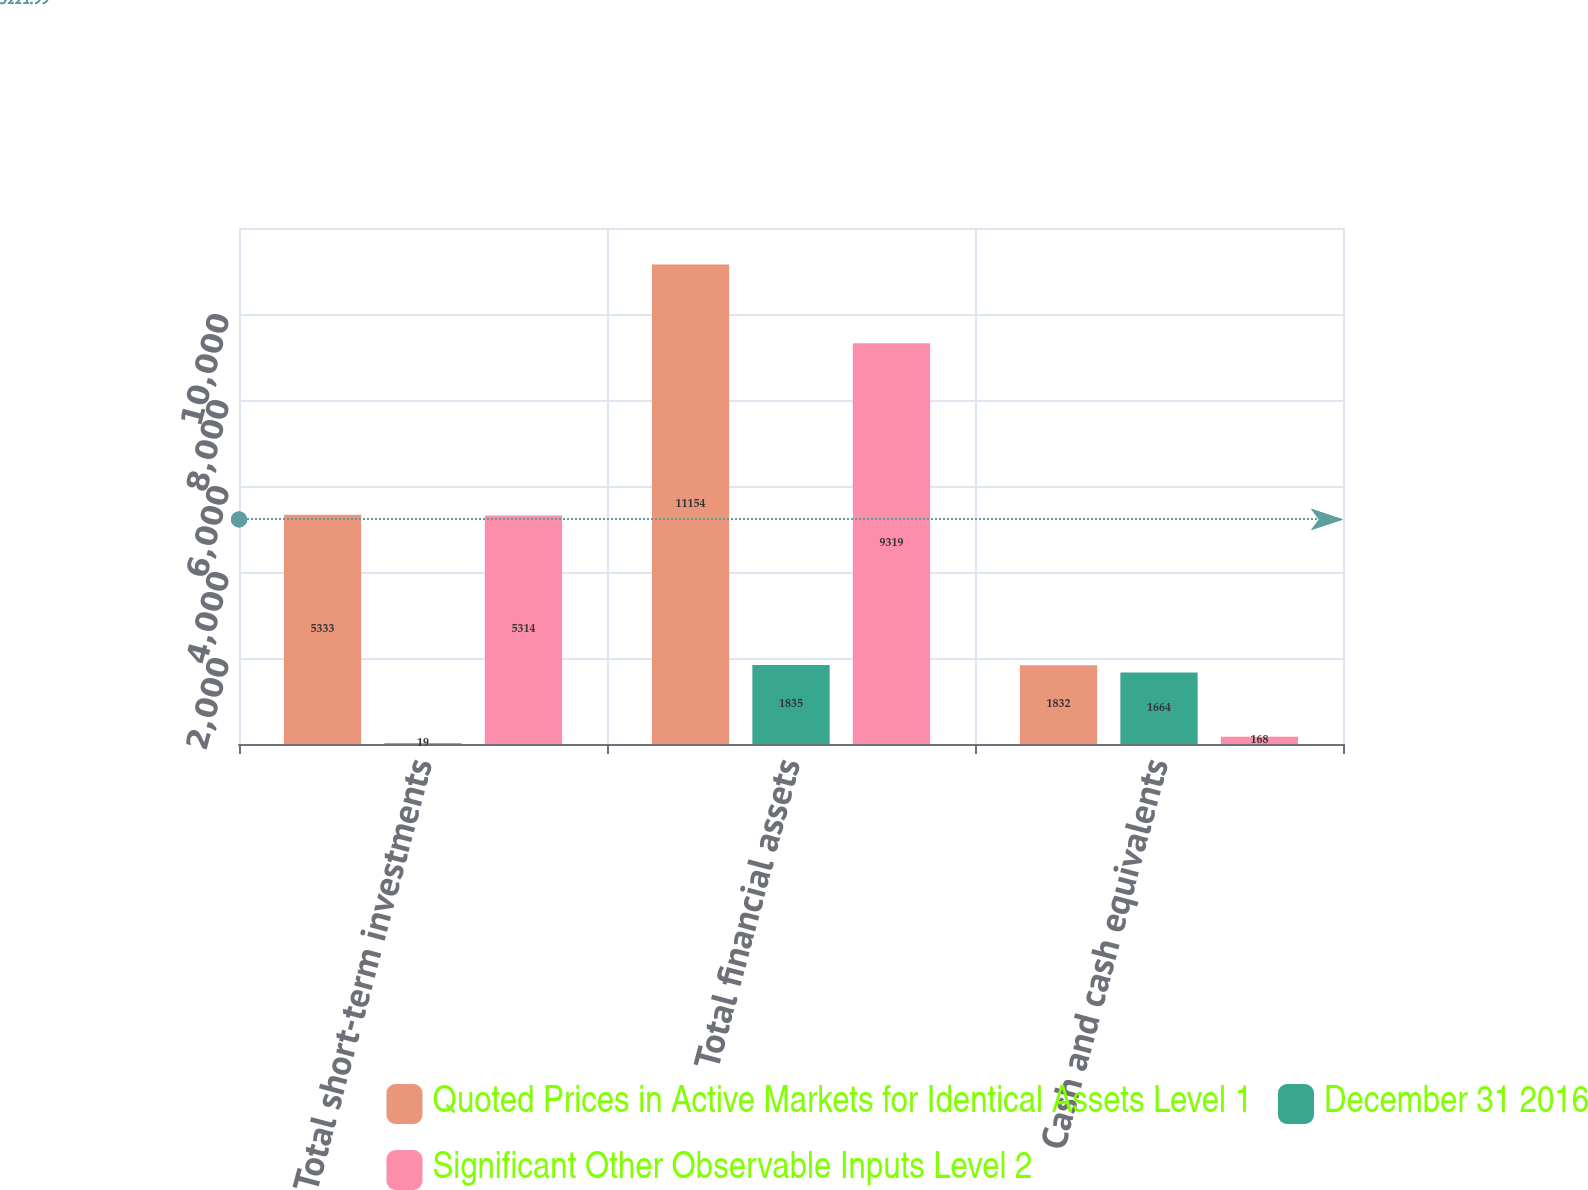Convert chart. <chart><loc_0><loc_0><loc_500><loc_500><stacked_bar_chart><ecel><fcel>Total short-term investments<fcel>Total financial assets<fcel>Cash and cash equivalents<nl><fcel>Quoted Prices in Active Markets for Identical Assets Level 1<fcel>5333<fcel>11154<fcel>1832<nl><fcel>December 31 2016<fcel>19<fcel>1835<fcel>1664<nl><fcel>Significant Other Observable Inputs Level 2<fcel>5314<fcel>9319<fcel>168<nl></chart> 